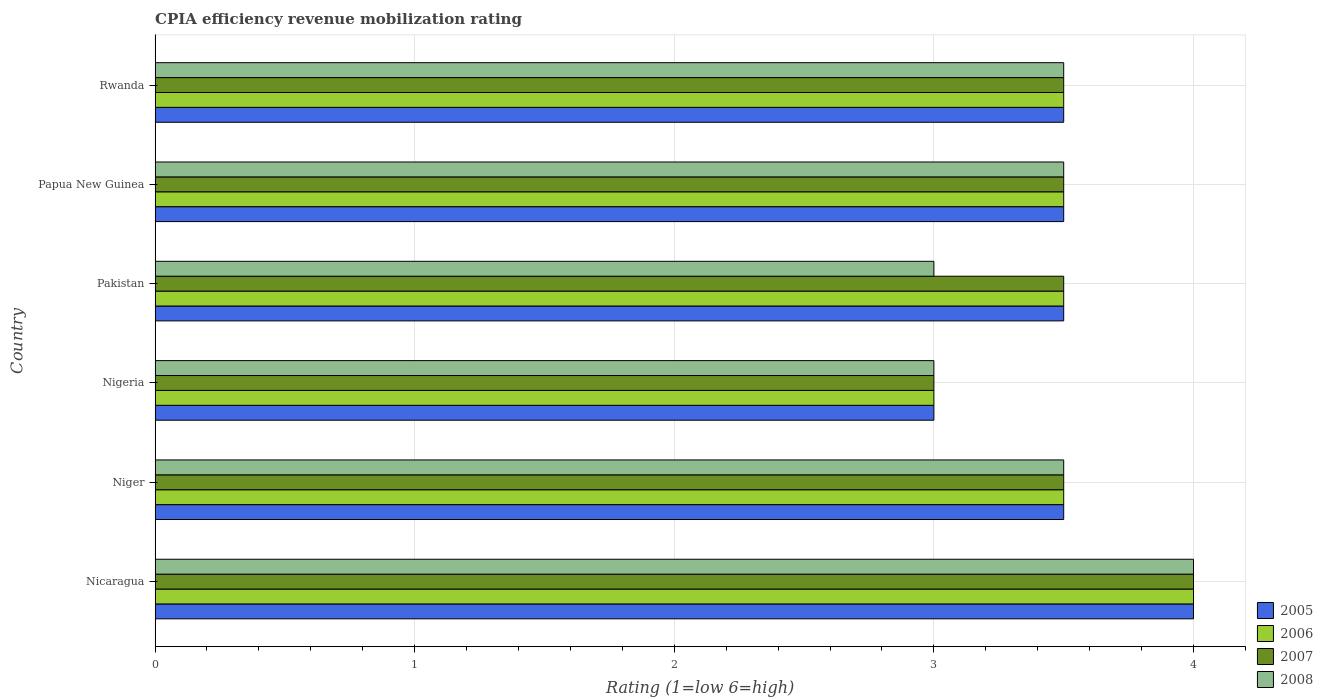How many different coloured bars are there?
Provide a short and direct response. 4. Are the number of bars per tick equal to the number of legend labels?
Keep it short and to the point. Yes. Are the number of bars on each tick of the Y-axis equal?
Provide a succinct answer. Yes. How many bars are there on the 3rd tick from the top?
Ensure brevity in your answer.  4. How many bars are there on the 6th tick from the bottom?
Offer a terse response. 4. What is the label of the 2nd group of bars from the top?
Your answer should be compact. Papua New Guinea. Across all countries, what is the maximum CPIA rating in 2007?
Offer a terse response. 4. In which country was the CPIA rating in 2005 maximum?
Your answer should be compact. Nicaragua. In which country was the CPIA rating in 2008 minimum?
Ensure brevity in your answer.  Nigeria. What is the total CPIA rating in 2008 in the graph?
Make the answer very short. 20.5. What is the difference between the CPIA rating in 2006 in Pakistan and that in Rwanda?
Provide a succinct answer. 0. What is the average CPIA rating in 2006 per country?
Make the answer very short. 3.5. What is the difference between the CPIA rating in 2008 and CPIA rating in 2007 in Pakistan?
Offer a terse response. -0.5. In how many countries, is the CPIA rating in 2007 greater than 1 ?
Your answer should be compact. 6. What is the ratio of the CPIA rating in 2006 in Niger to that in Papua New Guinea?
Your response must be concise. 1. Is the difference between the CPIA rating in 2008 in Niger and Papua New Guinea greater than the difference between the CPIA rating in 2007 in Niger and Papua New Guinea?
Provide a short and direct response. No. What is the difference between the highest and the second highest CPIA rating in 2008?
Give a very brief answer. 0.5. What is the difference between the highest and the lowest CPIA rating in 2008?
Ensure brevity in your answer.  1. Is the sum of the CPIA rating in 2005 in Niger and Papua New Guinea greater than the maximum CPIA rating in 2007 across all countries?
Ensure brevity in your answer.  Yes. Is it the case that in every country, the sum of the CPIA rating in 2006 and CPIA rating in 2005 is greater than the sum of CPIA rating in 2007 and CPIA rating in 2008?
Provide a short and direct response. No. What does the 3rd bar from the top in Rwanda represents?
Offer a terse response. 2006. What does the 3rd bar from the bottom in Nicaragua represents?
Make the answer very short. 2007. Is it the case that in every country, the sum of the CPIA rating in 2006 and CPIA rating in 2005 is greater than the CPIA rating in 2008?
Provide a short and direct response. Yes. How many bars are there?
Offer a terse response. 24. Are all the bars in the graph horizontal?
Make the answer very short. Yes. How many countries are there in the graph?
Your answer should be very brief. 6. Does the graph contain any zero values?
Offer a very short reply. No. Where does the legend appear in the graph?
Make the answer very short. Bottom right. How many legend labels are there?
Keep it short and to the point. 4. How are the legend labels stacked?
Offer a terse response. Vertical. What is the title of the graph?
Keep it short and to the point. CPIA efficiency revenue mobilization rating. Does "1994" appear as one of the legend labels in the graph?
Offer a terse response. No. What is the label or title of the X-axis?
Make the answer very short. Rating (1=low 6=high). What is the label or title of the Y-axis?
Provide a succinct answer. Country. What is the Rating (1=low 6=high) of 2005 in Nicaragua?
Offer a very short reply. 4. What is the Rating (1=low 6=high) in 2007 in Niger?
Keep it short and to the point. 3.5. What is the Rating (1=low 6=high) of 2007 in Nigeria?
Keep it short and to the point. 3. What is the Rating (1=low 6=high) of 2005 in Pakistan?
Keep it short and to the point. 3.5. What is the Rating (1=low 6=high) of 2006 in Pakistan?
Keep it short and to the point. 3.5. What is the Rating (1=low 6=high) of 2007 in Pakistan?
Provide a short and direct response. 3.5. What is the Rating (1=low 6=high) in 2005 in Papua New Guinea?
Give a very brief answer. 3.5. What is the Rating (1=low 6=high) in 2008 in Papua New Guinea?
Offer a terse response. 3.5. What is the Rating (1=low 6=high) in 2006 in Rwanda?
Your answer should be compact. 3.5. What is the Rating (1=low 6=high) in 2007 in Rwanda?
Ensure brevity in your answer.  3.5. Across all countries, what is the maximum Rating (1=low 6=high) in 2005?
Your answer should be compact. 4. Across all countries, what is the maximum Rating (1=low 6=high) in 2008?
Provide a short and direct response. 4. Across all countries, what is the minimum Rating (1=low 6=high) in 2005?
Provide a succinct answer. 3. What is the total Rating (1=low 6=high) of 2005 in the graph?
Keep it short and to the point. 21. What is the total Rating (1=low 6=high) in 2008 in the graph?
Offer a very short reply. 20.5. What is the difference between the Rating (1=low 6=high) of 2005 in Nicaragua and that in Niger?
Provide a succinct answer. 0.5. What is the difference between the Rating (1=low 6=high) in 2007 in Nicaragua and that in Niger?
Provide a short and direct response. 0.5. What is the difference between the Rating (1=low 6=high) of 2006 in Nicaragua and that in Nigeria?
Your answer should be very brief. 1. What is the difference between the Rating (1=low 6=high) of 2006 in Nicaragua and that in Pakistan?
Provide a succinct answer. 0.5. What is the difference between the Rating (1=low 6=high) of 2008 in Nicaragua and that in Pakistan?
Offer a very short reply. 1. What is the difference between the Rating (1=low 6=high) of 2005 in Nicaragua and that in Papua New Guinea?
Provide a succinct answer. 0.5. What is the difference between the Rating (1=low 6=high) in 2007 in Nicaragua and that in Papua New Guinea?
Offer a terse response. 0.5. What is the difference between the Rating (1=low 6=high) of 2008 in Nicaragua and that in Papua New Guinea?
Keep it short and to the point. 0.5. What is the difference between the Rating (1=low 6=high) of 2005 in Nicaragua and that in Rwanda?
Offer a terse response. 0.5. What is the difference between the Rating (1=low 6=high) in 2007 in Nicaragua and that in Rwanda?
Provide a short and direct response. 0.5. What is the difference between the Rating (1=low 6=high) in 2008 in Nicaragua and that in Rwanda?
Your response must be concise. 0.5. What is the difference between the Rating (1=low 6=high) in 2006 in Niger and that in Nigeria?
Offer a very short reply. 0.5. What is the difference between the Rating (1=low 6=high) in 2007 in Niger and that in Nigeria?
Provide a short and direct response. 0.5. What is the difference between the Rating (1=low 6=high) in 2008 in Niger and that in Nigeria?
Your answer should be very brief. 0.5. What is the difference between the Rating (1=low 6=high) of 2006 in Niger and that in Pakistan?
Offer a terse response. 0. What is the difference between the Rating (1=low 6=high) of 2007 in Niger and that in Pakistan?
Offer a terse response. 0. What is the difference between the Rating (1=low 6=high) of 2005 in Niger and that in Papua New Guinea?
Your answer should be compact. 0. What is the difference between the Rating (1=low 6=high) in 2007 in Niger and that in Papua New Guinea?
Make the answer very short. 0. What is the difference between the Rating (1=low 6=high) of 2008 in Niger and that in Papua New Guinea?
Keep it short and to the point. 0. What is the difference between the Rating (1=low 6=high) in 2006 in Niger and that in Rwanda?
Your answer should be compact. 0. What is the difference between the Rating (1=low 6=high) in 2008 in Niger and that in Rwanda?
Your answer should be very brief. 0. What is the difference between the Rating (1=low 6=high) of 2006 in Nigeria and that in Pakistan?
Your response must be concise. -0.5. What is the difference between the Rating (1=low 6=high) of 2006 in Nigeria and that in Papua New Guinea?
Make the answer very short. -0.5. What is the difference between the Rating (1=low 6=high) of 2007 in Nigeria and that in Papua New Guinea?
Offer a very short reply. -0.5. What is the difference between the Rating (1=low 6=high) of 2008 in Nigeria and that in Papua New Guinea?
Give a very brief answer. -0.5. What is the difference between the Rating (1=low 6=high) in 2007 in Nigeria and that in Rwanda?
Offer a very short reply. -0.5. What is the difference between the Rating (1=low 6=high) in 2008 in Nigeria and that in Rwanda?
Keep it short and to the point. -0.5. What is the difference between the Rating (1=low 6=high) of 2006 in Pakistan and that in Papua New Guinea?
Provide a succinct answer. 0. What is the difference between the Rating (1=low 6=high) in 2005 in Pakistan and that in Rwanda?
Keep it short and to the point. 0. What is the difference between the Rating (1=low 6=high) of 2006 in Pakistan and that in Rwanda?
Make the answer very short. 0. What is the difference between the Rating (1=low 6=high) of 2007 in Pakistan and that in Rwanda?
Your answer should be very brief. 0. What is the difference between the Rating (1=low 6=high) in 2008 in Pakistan and that in Rwanda?
Your answer should be compact. -0.5. What is the difference between the Rating (1=low 6=high) in 2005 in Papua New Guinea and that in Rwanda?
Provide a short and direct response. 0. What is the difference between the Rating (1=low 6=high) in 2006 in Papua New Guinea and that in Rwanda?
Provide a succinct answer. 0. What is the difference between the Rating (1=low 6=high) in 2008 in Papua New Guinea and that in Rwanda?
Your answer should be very brief. 0. What is the difference between the Rating (1=low 6=high) in 2006 in Nicaragua and the Rating (1=low 6=high) in 2007 in Niger?
Offer a terse response. 0.5. What is the difference between the Rating (1=low 6=high) in 2007 in Nicaragua and the Rating (1=low 6=high) in 2008 in Niger?
Provide a succinct answer. 0.5. What is the difference between the Rating (1=low 6=high) of 2005 in Nicaragua and the Rating (1=low 6=high) of 2006 in Nigeria?
Your answer should be compact. 1. What is the difference between the Rating (1=low 6=high) in 2005 in Nicaragua and the Rating (1=low 6=high) in 2007 in Nigeria?
Offer a terse response. 1. What is the difference between the Rating (1=low 6=high) in 2006 in Nicaragua and the Rating (1=low 6=high) in 2007 in Nigeria?
Your answer should be compact. 1. What is the difference between the Rating (1=low 6=high) of 2007 in Nicaragua and the Rating (1=low 6=high) of 2008 in Nigeria?
Give a very brief answer. 1. What is the difference between the Rating (1=low 6=high) in 2005 in Nicaragua and the Rating (1=low 6=high) in 2008 in Pakistan?
Your answer should be very brief. 1. What is the difference between the Rating (1=low 6=high) of 2006 in Nicaragua and the Rating (1=low 6=high) of 2008 in Pakistan?
Offer a terse response. 1. What is the difference between the Rating (1=low 6=high) in 2006 in Nicaragua and the Rating (1=low 6=high) in 2007 in Papua New Guinea?
Keep it short and to the point. 0.5. What is the difference between the Rating (1=low 6=high) of 2007 in Nicaragua and the Rating (1=low 6=high) of 2008 in Papua New Guinea?
Provide a short and direct response. 0.5. What is the difference between the Rating (1=low 6=high) in 2005 in Nicaragua and the Rating (1=low 6=high) in 2006 in Rwanda?
Ensure brevity in your answer.  0.5. What is the difference between the Rating (1=low 6=high) of 2005 in Nicaragua and the Rating (1=low 6=high) of 2007 in Rwanda?
Your answer should be very brief. 0.5. What is the difference between the Rating (1=low 6=high) of 2005 in Niger and the Rating (1=low 6=high) of 2006 in Nigeria?
Make the answer very short. 0.5. What is the difference between the Rating (1=low 6=high) of 2005 in Niger and the Rating (1=low 6=high) of 2008 in Nigeria?
Your answer should be compact. 0.5. What is the difference between the Rating (1=low 6=high) of 2007 in Niger and the Rating (1=low 6=high) of 2008 in Nigeria?
Make the answer very short. 0.5. What is the difference between the Rating (1=low 6=high) in 2005 in Niger and the Rating (1=low 6=high) in 2006 in Pakistan?
Keep it short and to the point. 0. What is the difference between the Rating (1=low 6=high) of 2005 in Niger and the Rating (1=low 6=high) of 2008 in Pakistan?
Your answer should be compact. 0.5. What is the difference between the Rating (1=low 6=high) of 2006 in Niger and the Rating (1=low 6=high) of 2007 in Pakistan?
Keep it short and to the point. 0. What is the difference between the Rating (1=low 6=high) in 2007 in Niger and the Rating (1=low 6=high) in 2008 in Pakistan?
Keep it short and to the point. 0.5. What is the difference between the Rating (1=low 6=high) of 2005 in Niger and the Rating (1=low 6=high) of 2006 in Papua New Guinea?
Ensure brevity in your answer.  0. What is the difference between the Rating (1=low 6=high) in 2005 in Niger and the Rating (1=low 6=high) in 2007 in Papua New Guinea?
Your answer should be compact. 0. What is the difference between the Rating (1=low 6=high) in 2006 in Niger and the Rating (1=low 6=high) in 2008 in Papua New Guinea?
Keep it short and to the point. 0. What is the difference between the Rating (1=low 6=high) of 2007 in Niger and the Rating (1=low 6=high) of 2008 in Papua New Guinea?
Offer a terse response. 0. What is the difference between the Rating (1=low 6=high) in 2005 in Niger and the Rating (1=low 6=high) in 2007 in Rwanda?
Your answer should be compact. 0. What is the difference between the Rating (1=low 6=high) of 2006 in Niger and the Rating (1=low 6=high) of 2008 in Rwanda?
Offer a very short reply. 0. What is the difference between the Rating (1=low 6=high) in 2005 in Nigeria and the Rating (1=low 6=high) in 2007 in Pakistan?
Keep it short and to the point. -0.5. What is the difference between the Rating (1=low 6=high) of 2005 in Nigeria and the Rating (1=low 6=high) of 2008 in Pakistan?
Provide a succinct answer. 0. What is the difference between the Rating (1=low 6=high) of 2006 in Nigeria and the Rating (1=low 6=high) of 2008 in Pakistan?
Offer a terse response. 0. What is the difference between the Rating (1=low 6=high) of 2007 in Nigeria and the Rating (1=low 6=high) of 2008 in Pakistan?
Provide a short and direct response. 0. What is the difference between the Rating (1=low 6=high) of 2005 in Nigeria and the Rating (1=low 6=high) of 2006 in Rwanda?
Provide a succinct answer. -0.5. What is the difference between the Rating (1=low 6=high) in 2005 in Nigeria and the Rating (1=low 6=high) in 2007 in Rwanda?
Provide a succinct answer. -0.5. What is the difference between the Rating (1=low 6=high) in 2005 in Nigeria and the Rating (1=low 6=high) in 2008 in Rwanda?
Your response must be concise. -0.5. What is the difference between the Rating (1=low 6=high) of 2006 in Nigeria and the Rating (1=low 6=high) of 2007 in Rwanda?
Provide a short and direct response. -0.5. What is the difference between the Rating (1=low 6=high) of 2007 in Nigeria and the Rating (1=low 6=high) of 2008 in Rwanda?
Provide a short and direct response. -0.5. What is the difference between the Rating (1=low 6=high) of 2005 in Pakistan and the Rating (1=low 6=high) of 2006 in Papua New Guinea?
Make the answer very short. 0. What is the difference between the Rating (1=low 6=high) in 2005 in Pakistan and the Rating (1=low 6=high) in 2007 in Papua New Guinea?
Keep it short and to the point. 0. What is the difference between the Rating (1=low 6=high) in 2005 in Pakistan and the Rating (1=low 6=high) in 2008 in Papua New Guinea?
Your answer should be very brief. 0. What is the difference between the Rating (1=low 6=high) in 2006 in Pakistan and the Rating (1=low 6=high) in 2008 in Rwanda?
Offer a terse response. 0. What is the difference between the Rating (1=low 6=high) in 2005 in Papua New Guinea and the Rating (1=low 6=high) in 2007 in Rwanda?
Provide a short and direct response. 0. What is the difference between the Rating (1=low 6=high) of 2006 in Papua New Guinea and the Rating (1=low 6=high) of 2007 in Rwanda?
Your response must be concise. 0. What is the difference between the Rating (1=low 6=high) of 2006 in Papua New Guinea and the Rating (1=low 6=high) of 2008 in Rwanda?
Make the answer very short. 0. What is the average Rating (1=low 6=high) of 2007 per country?
Provide a succinct answer. 3.5. What is the average Rating (1=low 6=high) of 2008 per country?
Your answer should be very brief. 3.42. What is the difference between the Rating (1=low 6=high) in 2005 and Rating (1=low 6=high) in 2006 in Nicaragua?
Your response must be concise. 0. What is the difference between the Rating (1=low 6=high) of 2005 and Rating (1=low 6=high) of 2006 in Niger?
Provide a short and direct response. 0. What is the difference between the Rating (1=low 6=high) of 2005 and Rating (1=low 6=high) of 2007 in Niger?
Give a very brief answer. 0. What is the difference between the Rating (1=low 6=high) of 2006 and Rating (1=low 6=high) of 2007 in Niger?
Your response must be concise. 0. What is the difference between the Rating (1=low 6=high) of 2007 and Rating (1=low 6=high) of 2008 in Nigeria?
Keep it short and to the point. 0. What is the difference between the Rating (1=low 6=high) in 2005 and Rating (1=low 6=high) in 2006 in Pakistan?
Your answer should be very brief. 0. What is the difference between the Rating (1=low 6=high) in 2005 and Rating (1=low 6=high) in 2007 in Pakistan?
Provide a short and direct response. 0. What is the difference between the Rating (1=low 6=high) of 2006 and Rating (1=low 6=high) of 2007 in Pakistan?
Your response must be concise. 0. What is the difference between the Rating (1=low 6=high) in 2006 and Rating (1=low 6=high) in 2008 in Pakistan?
Offer a terse response. 0.5. What is the difference between the Rating (1=low 6=high) of 2007 and Rating (1=low 6=high) of 2008 in Pakistan?
Offer a very short reply. 0.5. What is the difference between the Rating (1=low 6=high) of 2005 and Rating (1=low 6=high) of 2006 in Papua New Guinea?
Your response must be concise. 0. What is the difference between the Rating (1=low 6=high) of 2005 and Rating (1=low 6=high) of 2007 in Papua New Guinea?
Your answer should be very brief. 0. What is the difference between the Rating (1=low 6=high) in 2005 and Rating (1=low 6=high) in 2008 in Papua New Guinea?
Provide a short and direct response. 0. What is the difference between the Rating (1=low 6=high) of 2006 and Rating (1=low 6=high) of 2008 in Papua New Guinea?
Provide a short and direct response. 0. What is the difference between the Rating (1=low 6=high) of 2005 and Rating (1=low 6=high) of 2006 in Rwanda?
Offer a very short reply. 0. What is the difference between the Rating (1=low 6=high) in 2005 and Rating (1=low 6=high) in 2007 in Rwanda?
Your answer should be very brief. 0. What is the difference between the Rating (1=low 6=high) of 2005 and Rating (1=low 6=high) of 2008 in Rwanda?
Make the answer very short. 0. What is the difference between the Rating (1=low 6=high) of 2006 and Rating (1=low 6=high) of 2007 in Rwanda?
Your answer should be compact. 0. What is the difference between the Rating (1=low 6=high) in 2007 and Rating (1=low 6=high) in 2008 in Rwanda?
Your answer should be compact. 0. What is the ratio of the Rating (1=low 6=high) in 2006 in Nicaragua to that in Niger?
Offer a very short reply. 1.14. What is the ratio of the Rating (1=low 6=high) in 2006 in Nicaragua to that in Nigeria?
Provide a succinct answer. 1.33. What is the ratio of the Rating (1=low 6=high) in 2008 in Nicaragua to that in Nigeria?
Your response must be concise. 1.33. What is the ratio of the Rating (1=low 6=high) of 2007 in Nicaragua to that in Pakistan?
Your response must be concise. 1.14. What is the ratio of the Rating (1=low 6=high) of 2007 in Nicaragua to that in Papua New Guinea?
Your response must be concise. 1.14. What is the ratio of the Rating (1=low 6=high) in 2006 in Nicaragua to that in Rwanda?
Ensure brevity in your answer.  1.14. What is the ratio of the Rating (1=low 6=high) in 2008 in Nicaragua to that in Rwanda?
Offer a very short reply. 1.14. What is the ratio of the Rating (1=low 6=high) in 2007 in Niger to that in Nigeria?
Provide a succinct answer. 1.17. What is the ratio of the Rating (1=low 6=high) of 2005 in Niger to that in Pakistan?
Your answer should be compact. 1. What is the ratio of the Rating (1=low 6=high) of 2006 in Niger to that in Pakistan?
Ensure brevity in your answer.  1. What is the ratio of the Rating (1=low 6=high) in 2008 in Niger to that in Pakistan?
Your answer should be compact. 1.17. What is the ratio of the Rating (1=low 6=high) in 2006 in Niger to that in Papua New Guinea?
Provide a short and direct response. 1. What is the ratio of the Rating (1=low 6=high) in 2006 in Niger to that in Rwanda?
Your answer should be compact. 1. What is the ratio of the Rating (1=low 6=high) in 2008 in Niger to that in Rwanda?
Ensure brevity in your answer.  1. What is the ratio of the Rating (1=low 6=high) of 2007 in Nigeria to that in Pakistan?
Provide a short and direct response. 0.86. What is the ratio of the Rating (1=low 6=high) of 2008 in Nigeria to that in Pakistan?
Your answer should be compact. 1. What is the ratio of the Rating (1=low 6=high) of 2005 in Nigeria to that in Papua New Guinea?
Offer a terse response. 0.86. What is the ratio of the Rating (1=low 6=high) in 2006 in Nigeria to that in Rwanda?
Your answer should be very brief. 0.86. What is the ratio of the Rating (1=low 6=high) of 2008 in Nigeria to that in Rwanda?
Offer a very short reply. 0.86. What is the ratio of the Rating (1=low 6=high) of 2005 in Pakistan to that in Rwanda?
Make the answer very short. 1. What is the ratio of the Rating (1=low 6=high) of 2007 in Pakistan to that in Rwanda?
Your response must be concise. 1. What is the ratio of the Rating (1=low 6=high) of 2008 in Pakistan to that in Rwanda?
Your response must be concise. 0.86. What is the ratio of the Rating (1=low 6=high) of 2005 in Papua New Guinea to that in Rwanda?
Offer a terse response. 1. What is the ratio of the Rating (1=low 6=high) of 2006 in Papua New Guinea to that in Rwanda?
Ensure brevity in your answer.  1. What is the ratio of the Rating (1=low 6=high) of 2007 in Papua New Guinea to that in Rwanda?
Provide a short and direct response. 1. What is the difference between the highest and the second highest Rating (1=low 6=high) of 2005?
Your answer should be very brief. 0.5. What is the difference between the highest and the second highest Rating (1=low 6=high) of 2008?
Provide a succinct answer. 0.5. What is the difference between the highest and the lowest Rating (1=low 6=high) of 2005?
Provide a short and direct response. 1. What is the difference between the highest and the lowest Rating (1=low 6=high) of 2006?
Offer a very short reply. 1. What is the difference between the highest and the lowest Rating (1=low 6=high) of 2007?
Your response must be concise. 1. 